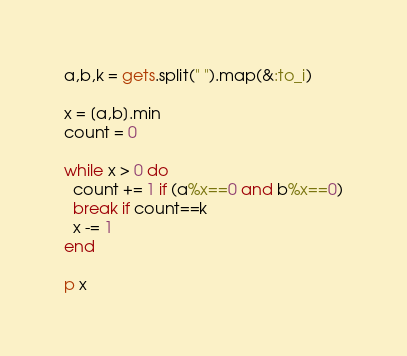<code> <loc_0><loc_0><loc_500><loc_500><_Ruby_>a,b,k = gets.split(" ").map(&:to_i)

x = [a,b].min
count = 0

while x > 0 do
  count += 1 if (a%x==0 and b%x==0)
  break if count==k
  x -= 1
end

p x</code> 